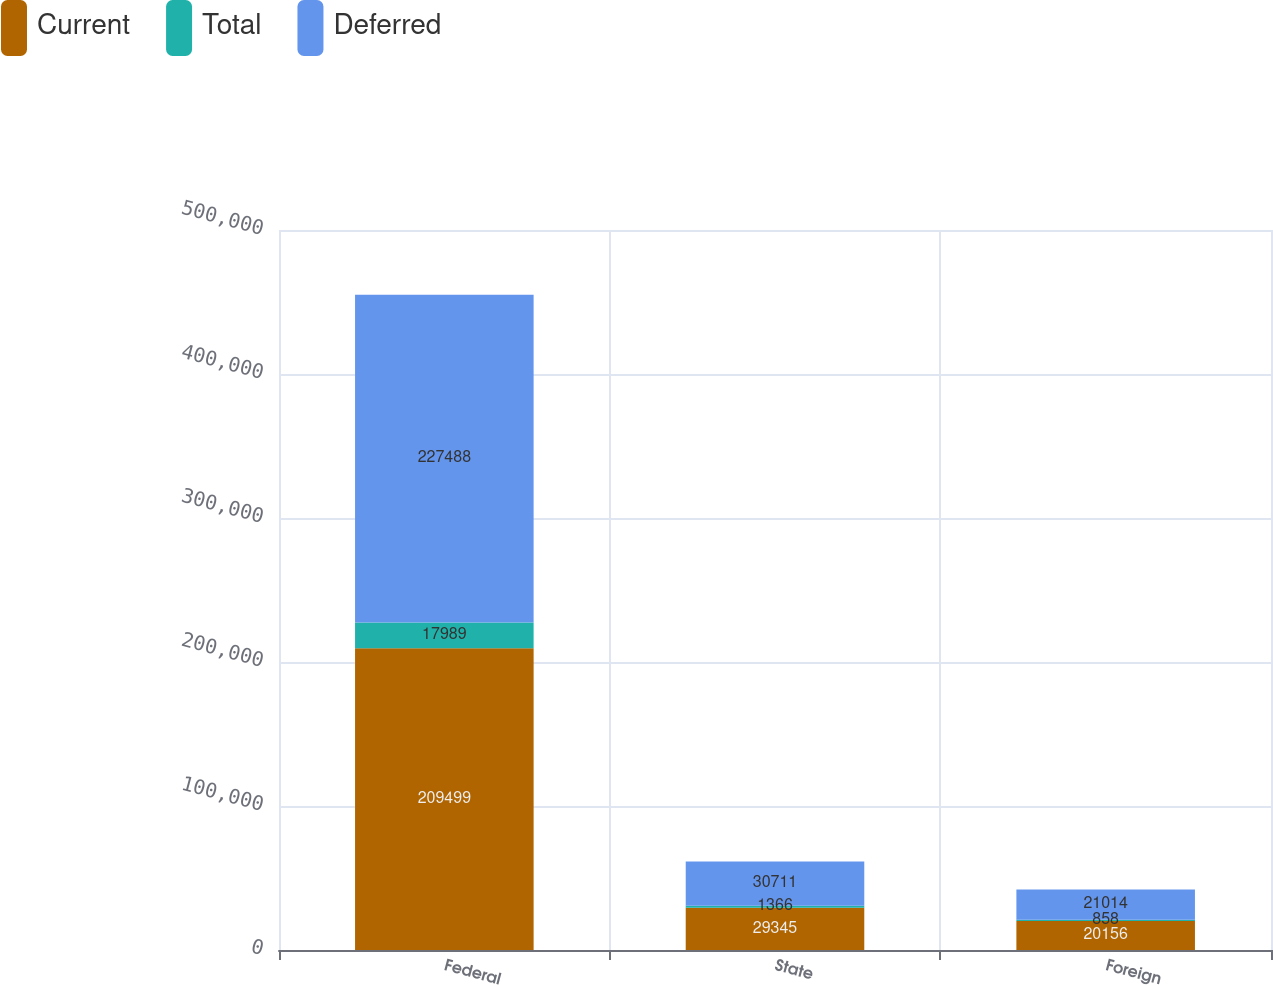Convert chart. <chart><loc_0><loc_0><loc_500><loc_500><stacked_bar_chart><ecel><fcel>Federal<fcel>State<fcel>Foreign<nl><fcel>Current<fcel>209499<fcel>29345<fcel>20156<nl><fcel>Total<fcel>17989<fcel>1366<fcel>858<nl><fcel>Deferred<fcel>227488<fcel>30711<fcel>21014<nl></chart> 